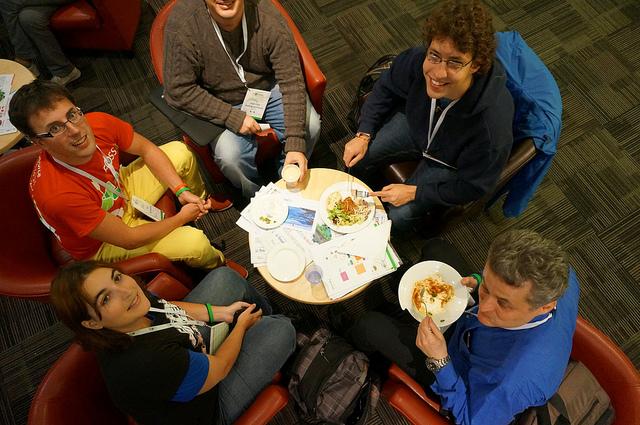Where is the mushroom?
Short answer required. Plate. Does the employer of these individuals require business dress?
Answer briefly. No. Is one of the men wearing glasses?
Answer briefly. Yes. Are all the people in this picture the same gender?
Give a very brief answer. No. 